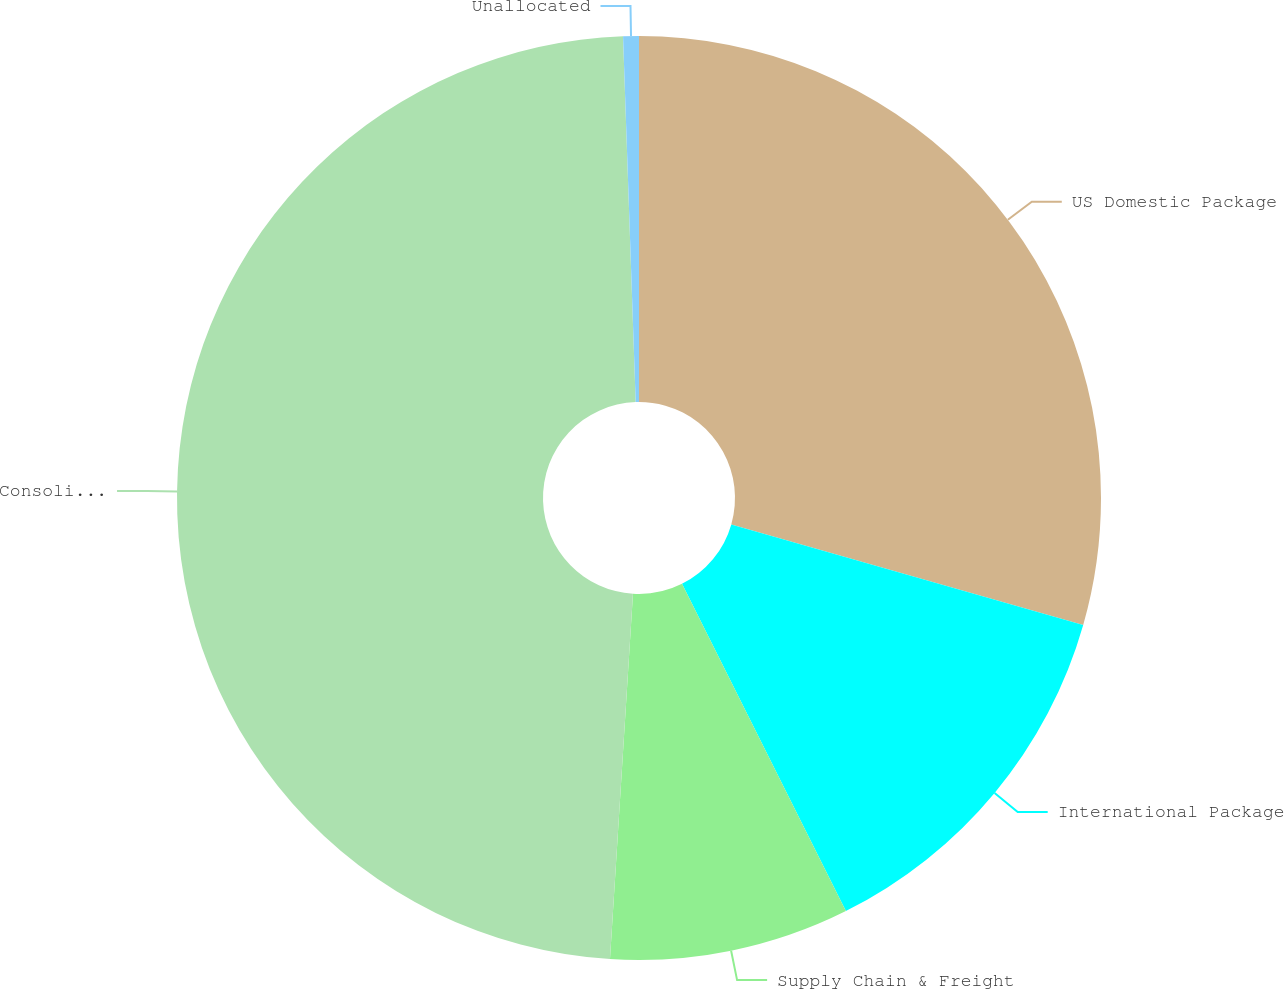Convert chart. <chart><loc_0><loc_0><loc_500><loc_500><pie_chart><fcel>US Domestic Package<fcel>International Package<fcel>Supply Chain & Freight<fcel>Consolidated<fcel>Unallocated<nl><fcel>29.43%<fcel>13.18%<fcel>8.39%<fcel>48.45%<fcel>0.55%<nl></chart> 